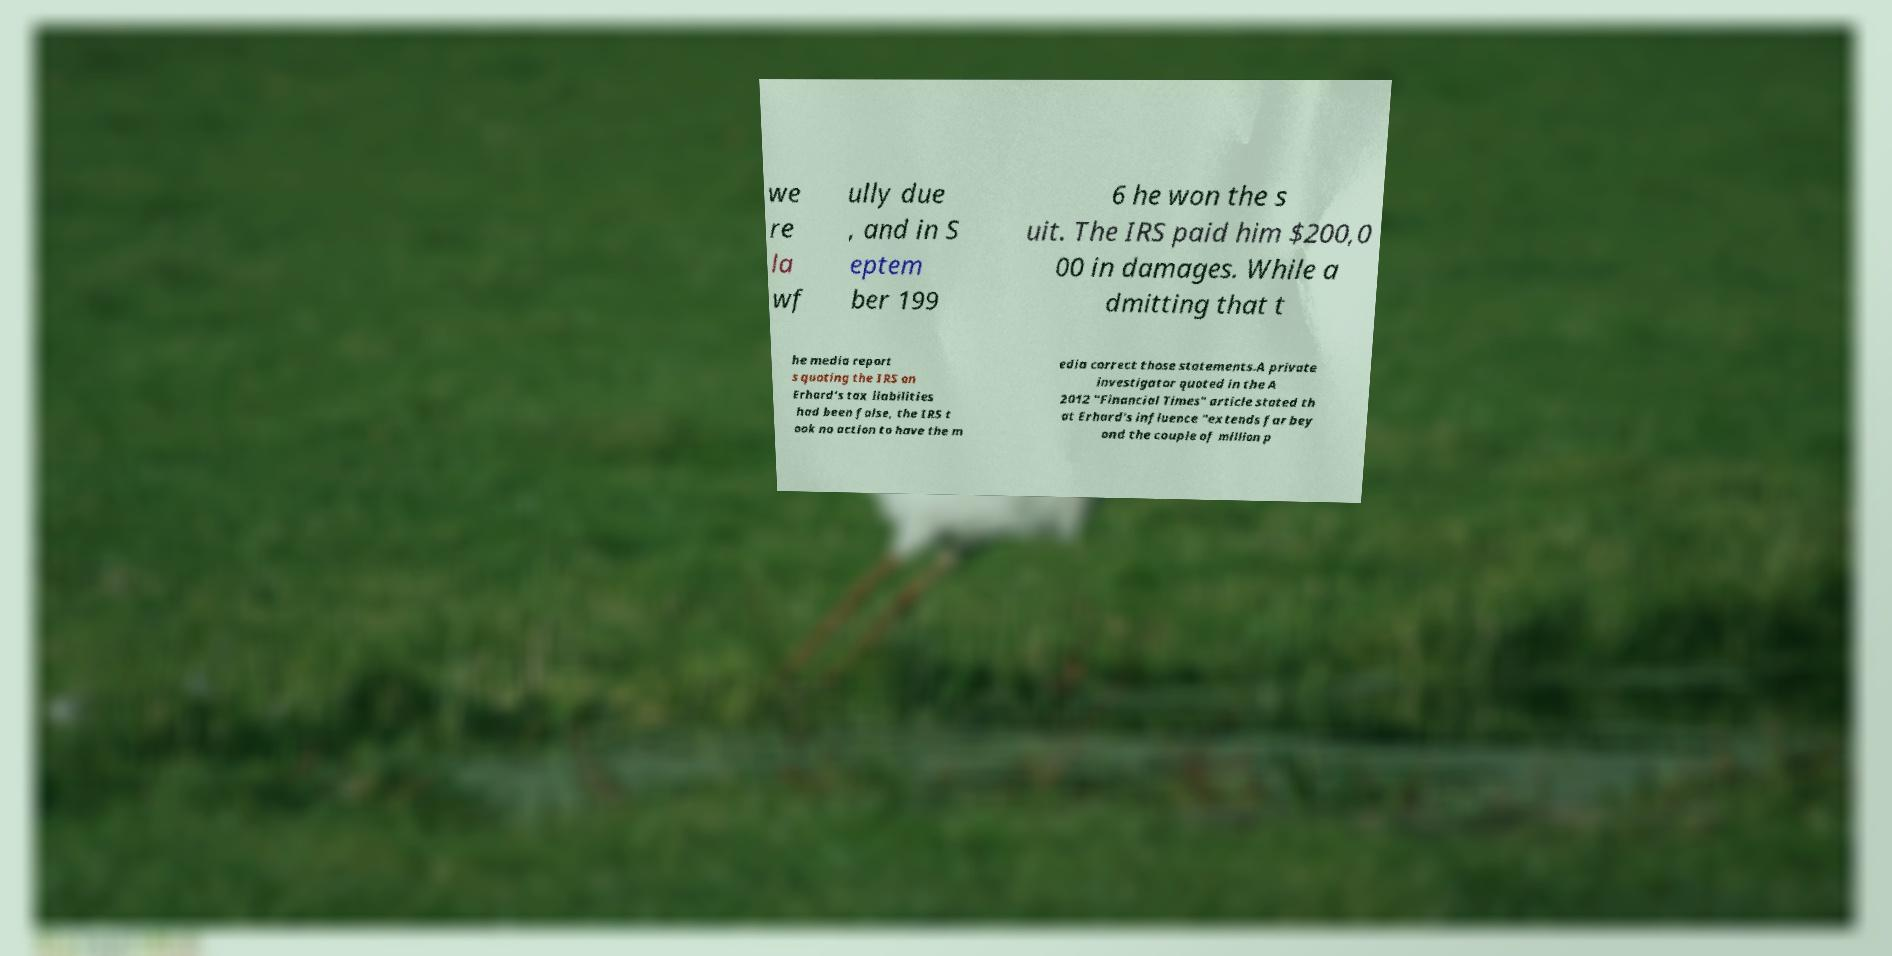For documentation purposes, I need the text within this image transcribed. Could you provide that? we re la wf ully due , and in S eptem ber 199 6 he won the s uit. The IRS paid him $200,0 00 in damages. While a dmitting that t he media report s quoting the IRS on Erhard's tax liabilities had been false, the IRS t ook no action to have the m edia correct those statements.A private investigator quoted in the A 2012 "Financial Times" article stated th at Erhard's influence "extends far bey ond the couple of million p 